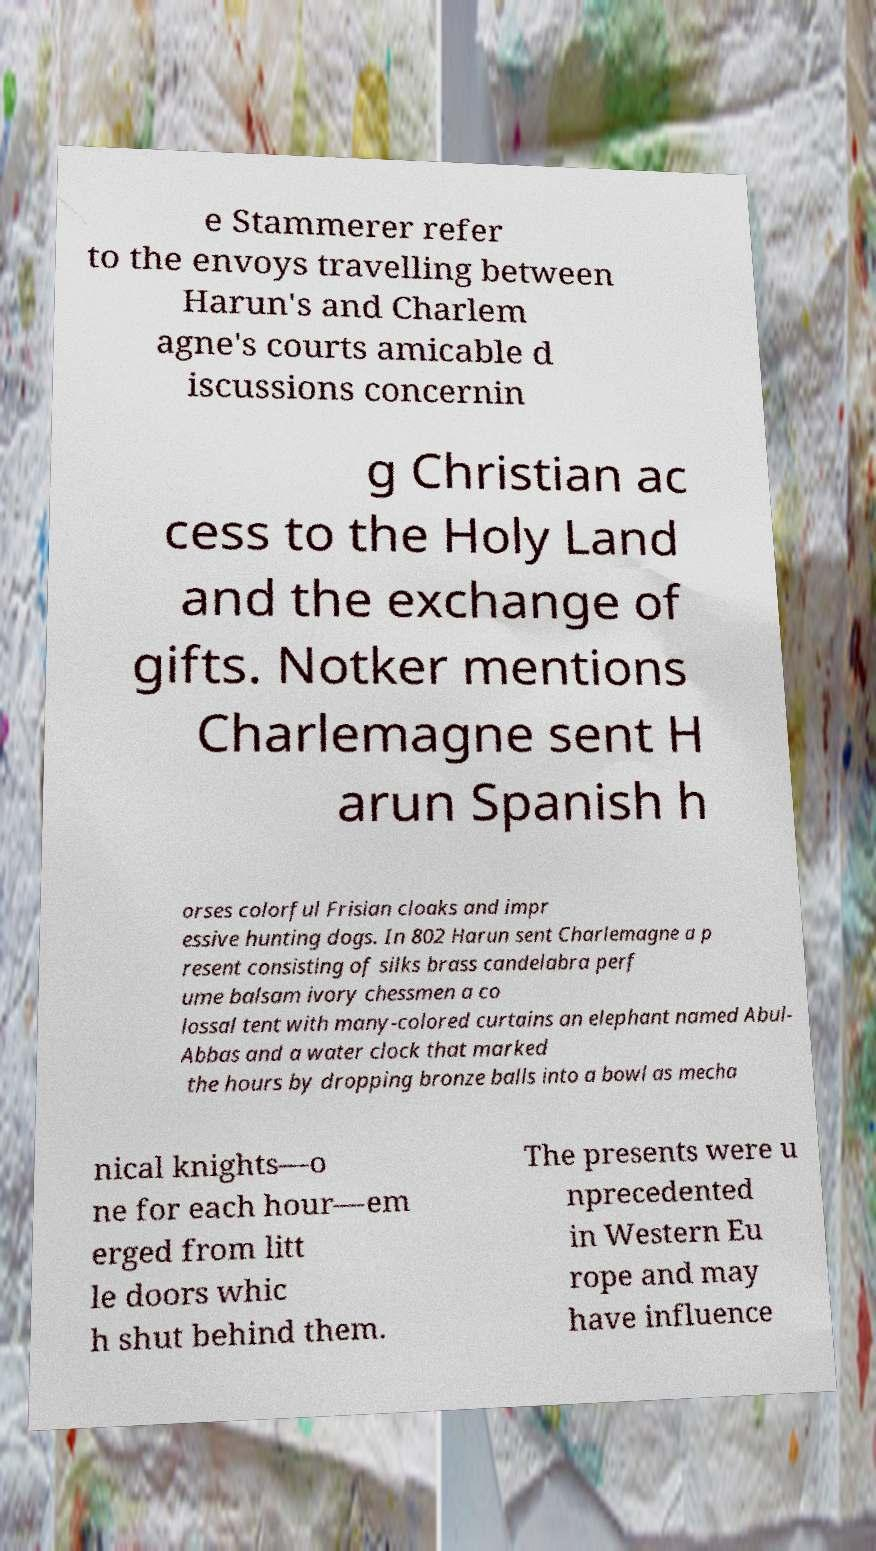Can you read and provide the text displayed in the image?This photo seems to have some interesting text. Can you extract and type it out for me? e Stammerer refer to the envoys travelling between Harun's and Charlem agne's courts amicable d iscussions concernin g Christian ac cess to the Holy Land and the exchange of gifts. Notker mentions Charlemagne sent H arun Spanish h orses colorful Frisian cloaks and impr essive hunting dogs. In 802 Harun sent Charlemagne a p resent consisting of silks brass candelabra perf ume balsam ivory chessmen a co lossal tent with many-colored curtains an elephant named Abul- Abbas and a water clock that marked the hours by dropping bronze balls into a bowl as mecha nical knights—o ne for each hour—em erged from litt le doors whic h shut behind them. The presents were u nprecedented in Western Eu rope and may have influence 